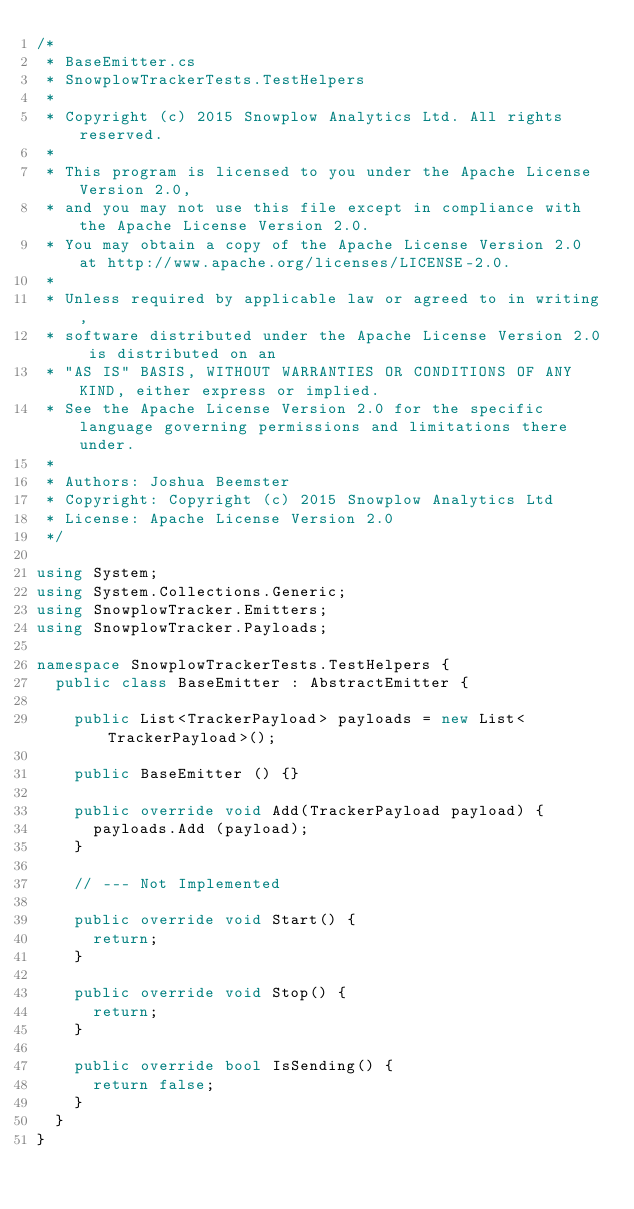<code> <loc_0><loc_0><loc_500><loc_500><_C#_>/*
 * BaseEmitter.cs
 * SnowplowTrackerTests.TestHelpers
 * 
 * Copyright (c) 2015 Snowplow Analytics Ltd. All rights reserved.
 *
 * This program is licensed to you under the Apache License Version 2.0,
 * and you may not use this file except in compliance with the Apache License Version 2.0.
 * You may obtain a copy of the Apache License Version 2.0 at http://www.apache.org/licenses/LICENSE-2.0.
 *
 * Unless required by applicable law or agreed to in writing,
 * software distributed under the Apache License Version 2.0 is distributed on an
 * "AS IS" BASIS, WITHOUT WARRANTIES OR CONDITIONS OF ANY KIND, either express or implied.
 * See the Apache License Version 2.0 for the specific language governing permissions and limitations there under.
 * 
 * Authors: Joshua Beemster
 * Copyright: Copyright (c) 2015 Snowplow Analytics Ltd
 * License: Apache License Version 2.0
 */

using System;
using System.Collections.Generic;
using SnowplowTracker.Emitters;
using SnowplowTracker.Payloads;

namespace SnowplowTrackerTests.TestHelpers {
	public class BaseEmitter : AbstractEmitter {

		public List<TrackerPayload> payloads = new List<TrackerPayload>();

		public BaseEmitter () {}

		public override void Add(TrackerPayload payload) {
			payloads.Add (payload);
		}

		// --- Not Implemented

		public override void Start() {
			return;
		}

		public override void Stop() {
			return;
		}

		public override bool IsSending() {
			return false;	
		}
	}
}
</code> 